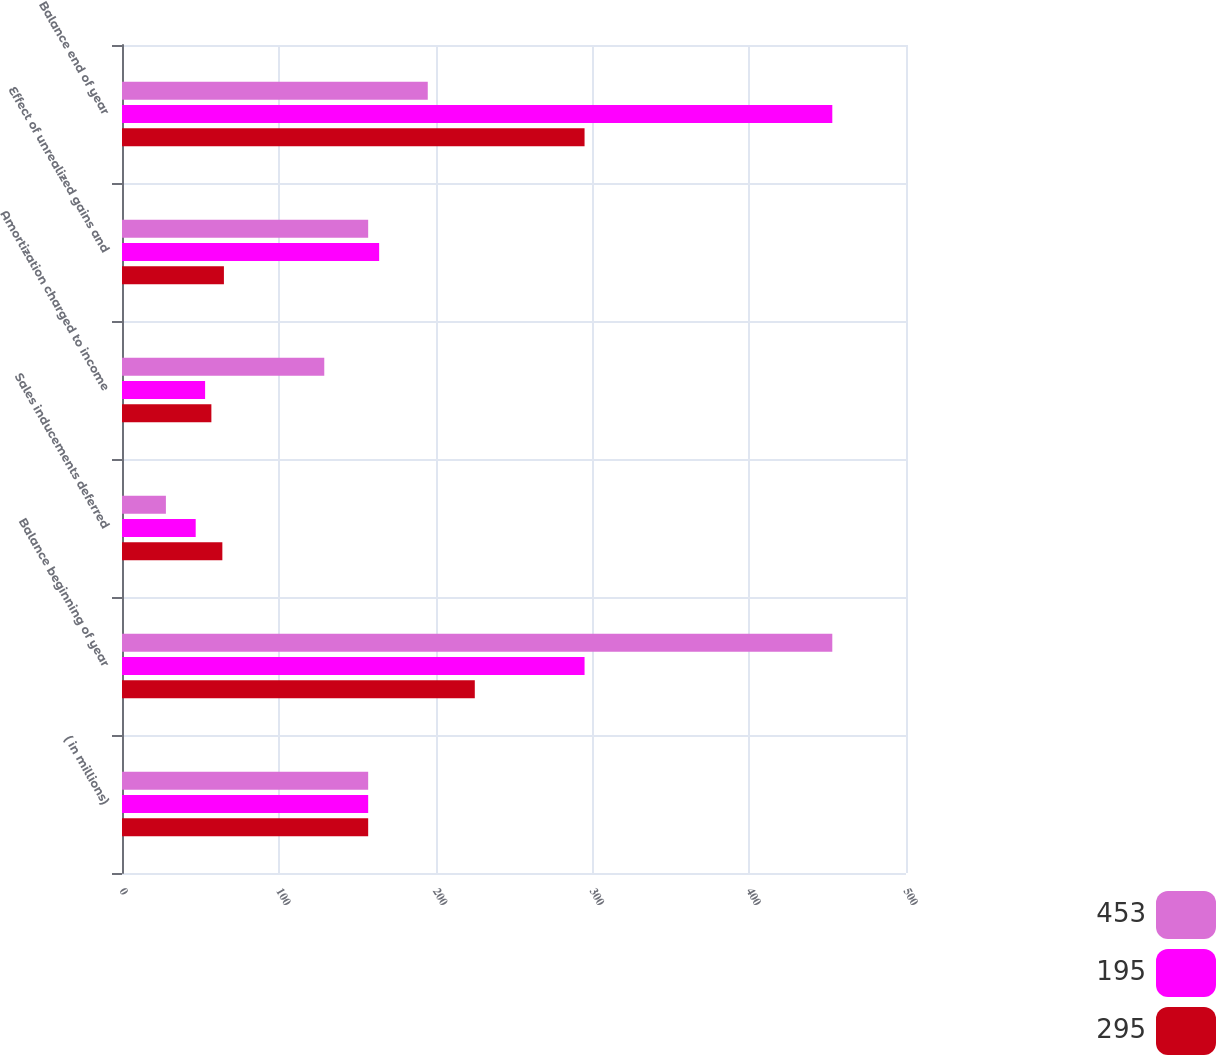Convert chart to OTSL. <chart><loc_0><loc_0><loc_500><loc_500><stacked_bar_chart><ecel><fcel>( in millions)<fcel>Balance beginning of year<fcel>Sales inducements deferred<fcel>Amortization charged to income<fcel>Effect of unrealized gains and<fcel>Balance end of year<nl><fcel>453<fcel>157<fcel>453<fcel>28<fcel>129<fcel>157<fcel>195<nl><fcel>195<fcel>157<fcel>295<fcel>47<fcel>53<fcel>164<fcel>453<nl><fcel>295<fcel>157<fcel>225<fcel>64<fcel>57<fcel>65<fcel>295<nl></chart> 